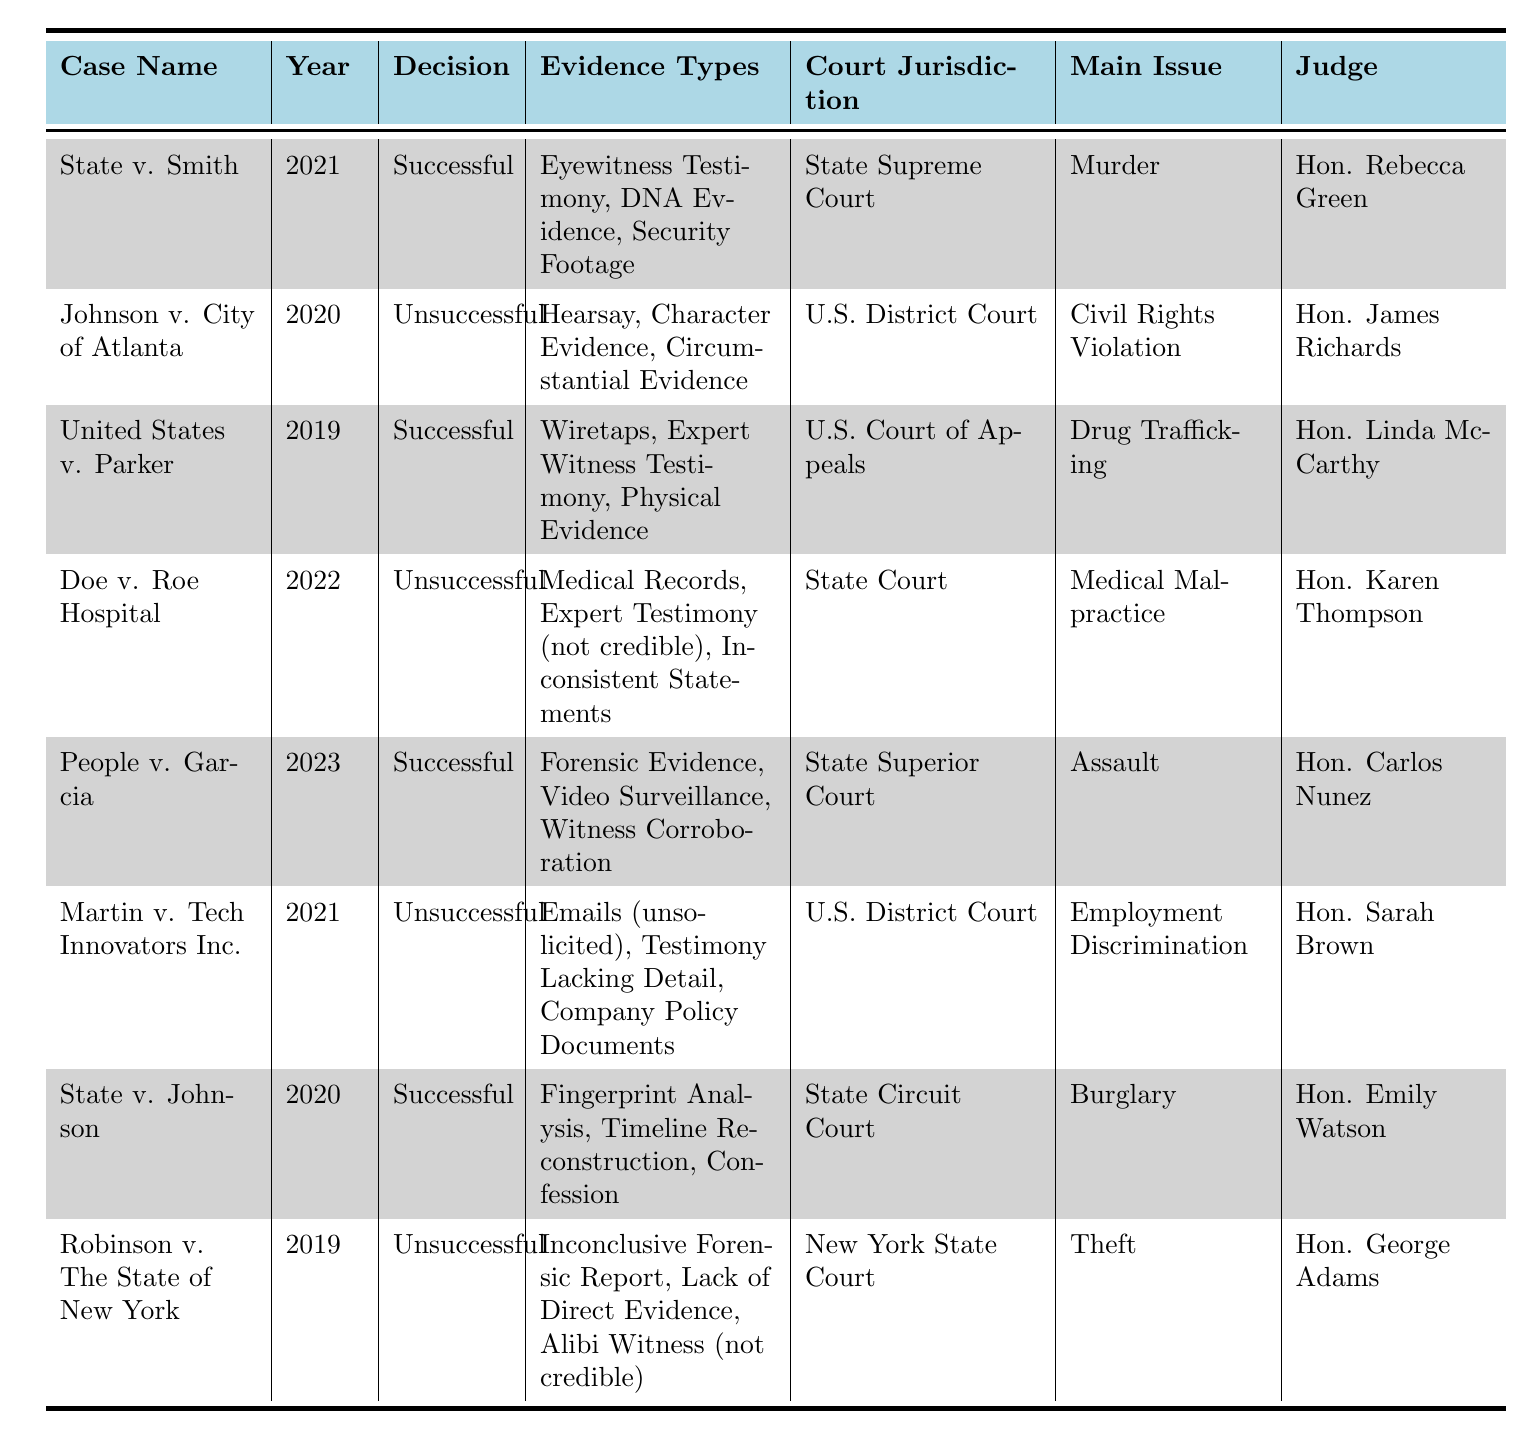What is the main issue in the case "Doe v. Roe Hospital"? The table lists "Medical Malpractice" as the main issue for "Doe v. Roe Hospital."
Answer: Medical Malpractice Which jurisdiction handled the case "People v. Garcia"? According to the table, "People v. Garcia" was handled by the State Superior Court.
Answer: State Superior Court In which year did the case "State v. Smith" occur? The year for "State v. Smith" is specified in the table as 2021.
Answer: 2021 How many cases were successful? There are four cases marked as successful in the table: "State v. Smith," "United States v. Parker," "People v. Garcia," and "State v. Johnson."
Answer: 4 What types of evidence were used in the unsuccessful case "Johnson v. City of Atlanta"? The evidence types for "Johnson v. City of Atlanta" are Hearsay, Character Evidence, and Circumstantial Evidence, as listed in the table.
Answer: Hearsay, Character Evidence, Circumstantial Evidence Which judge presided over the case "Robinson v. The State of New York"? The table indicates that Hon. George Adams was the judge for "Robinson v. The State of New York."
Answer: Hon. George Adams What are the common types of evidence in successful cases compared to unsuccessful ones? Successful cases often include concrete evidence types like DNA Evidence and Forensic Evidence, while unsuccessful cases frequently list hearsay or non-credible evidence.
Answer: Concrete evidence vs. hearsay/non-credible evidence Are there more cases decided successfully or unsuccessfully? There are four successful cases and four unsuccessful cases listed in the table, indicating they are equal in number.
Answer: Equal What evidence types were present in both successful and unsuccessful cases? The table does not show any common evidence types present in both categories; successful cases used definitive evidence whereas unsuccessful cases used less credible types.
Answer: No common evidence types Which case had a decision based on "Expert Testimony"? The case "United States v. Parker" had a decision based on "Expert Witness Testimony," which is listed as a successful evidence type.
Answer: United States v. Parker What is the difference in evidence types between "State v. Johnson" and "Martin v. Tech Innovators Inc."? "State v. Johnson" used Fingerprint Analysis, Timeline Reconstruction, and Confession, while "Martin v. Tech Innovators Inc." relied on Emails (unsolicited), Testimony Lacking Detail, and Company Policy Documents, indicating the former had more credible evidence.
Answer: Credible vs. less credible evidence types 